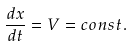<formula> <loc_0><loc_0><loc_500><loc_500>\frac { d x } { d t } = V = c o n s t .</formula> 